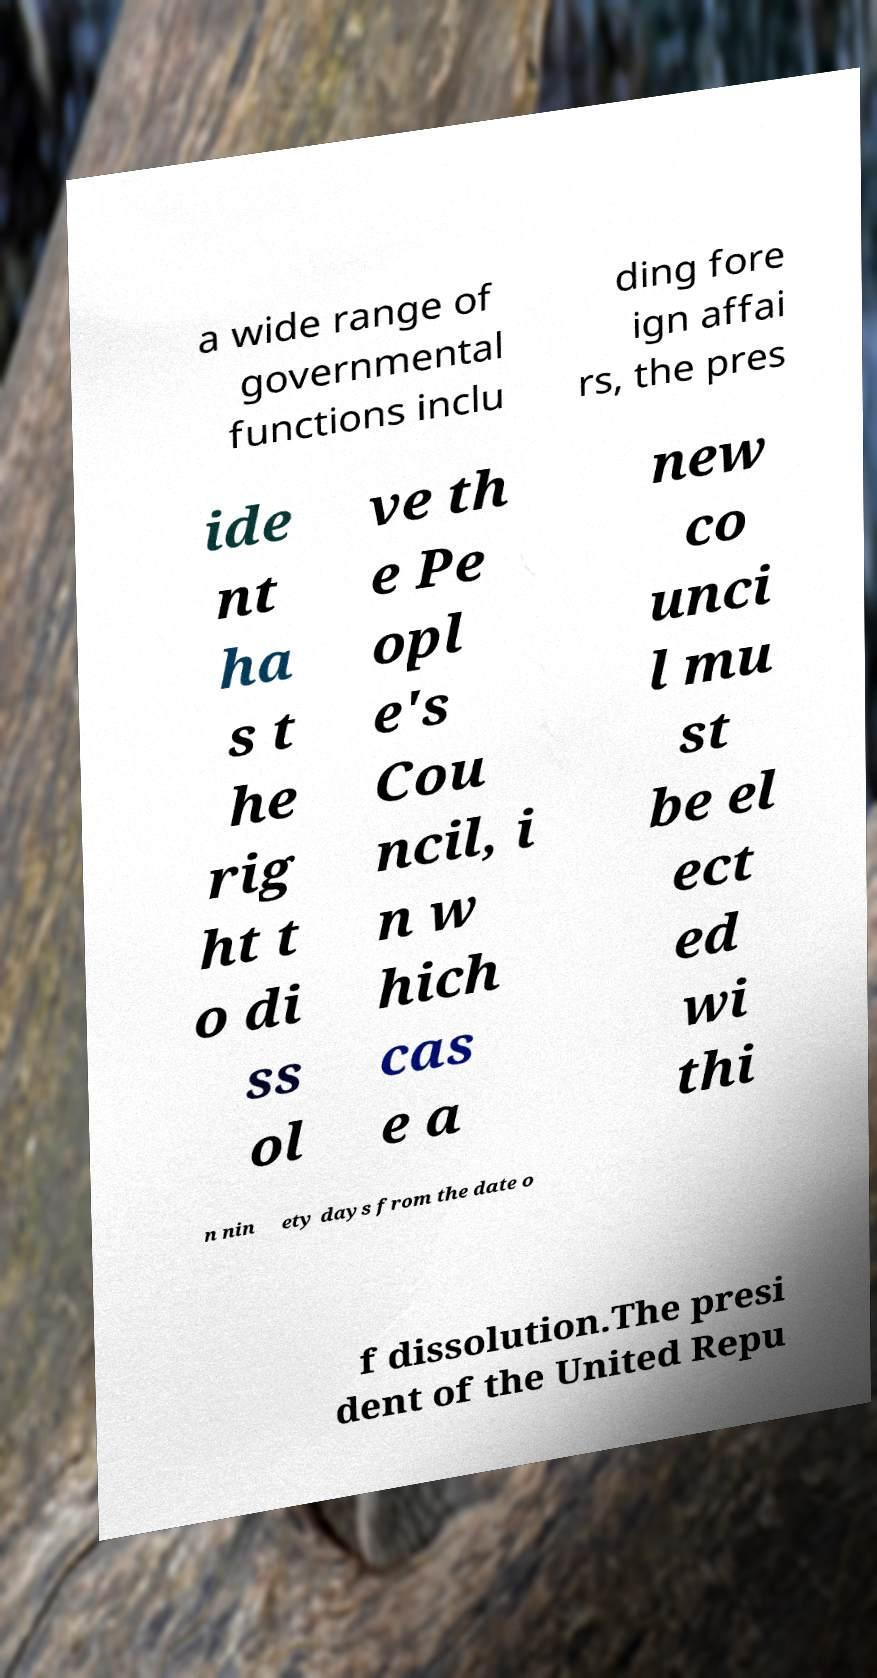Please identify and transcribe the text found in this image. a wide range of governmental functions inclu ding fore ign affai rs, the pres ide nt ha s t he rig ht t o di ss ol ve th e Pe opl e's Cou ncil, i n w hich cas e a new co unci l mu st be el ect ed wi thi n nin ety days from the date o f dissolution.The presi dent of the United Repu 